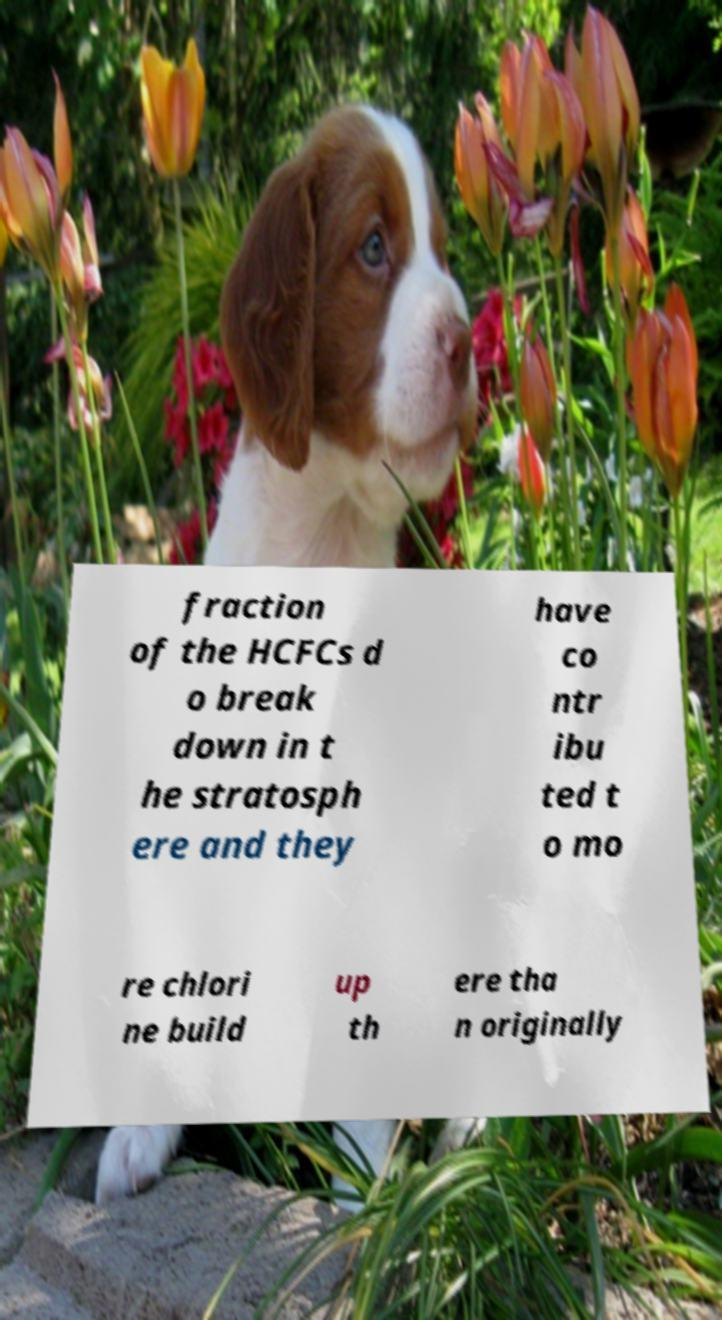Could you extract and type out the text from this image? fraction of the HCFCs d o break down in t he stratosph ere and they have co ntr ibu ted t o mo re chlori ne build up th ere tha n originally 